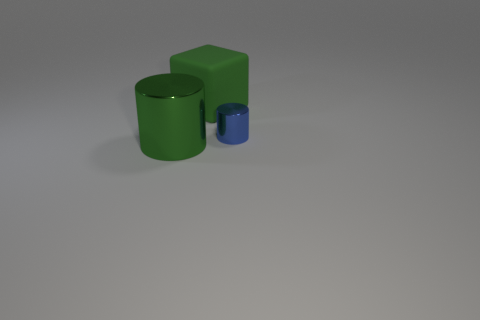Add 1 cyan shiny cylinders. How many objects exist? 4 Subtract all cylinders. How many objects are left? 1 Add 3 big green cubes. How many big green cubes exist? 4 Subtract 0 red cubes. How many objects are left? 3 Subtract all green cylinders. Subtract all blue rubber cylinders. How many objects are left? 2 Add 2 small blue objects. How many small blue objects are left? 3 